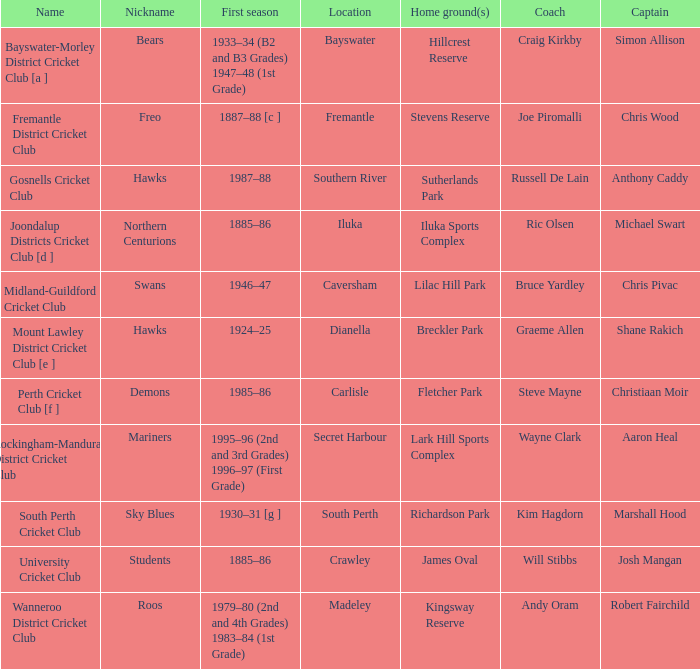At caversham, what is the name of the skipper? Chris Pivac. 